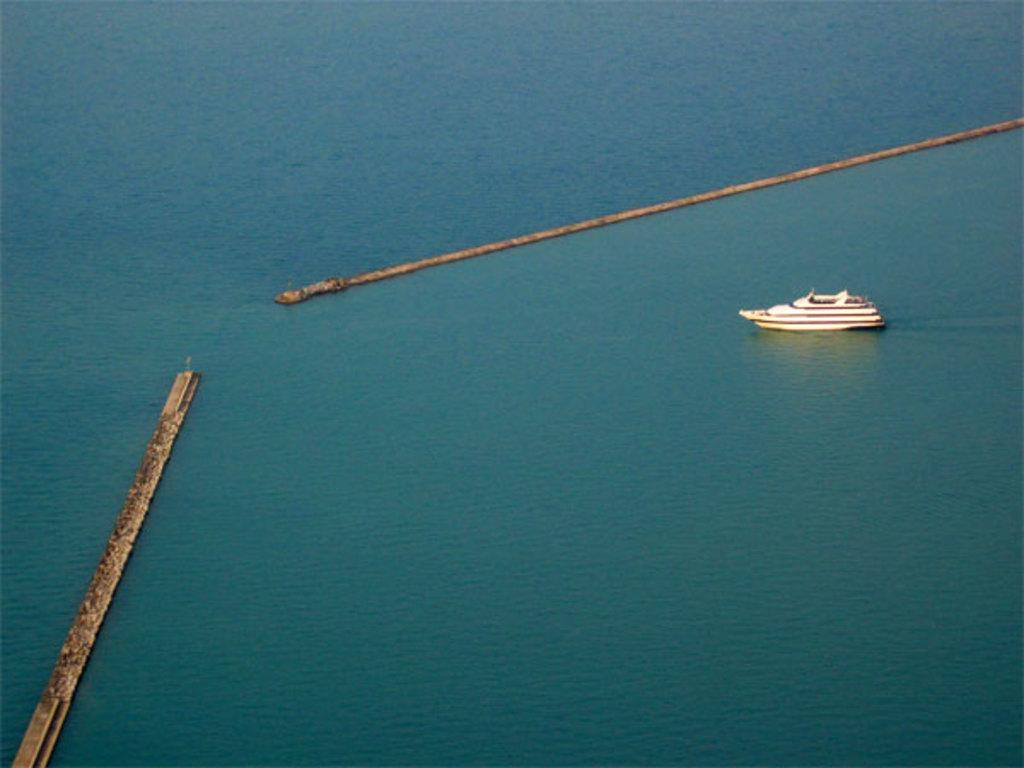What is the main subject of the image? The main subject of the image is a boat. Where is the boat located in the image? The boat is in the water. What other object can be seen in the image? There is a fence in the image. Can you describe the setting of the image? The image may have been taken in the ocean, given the presence of water. What type of butter is being used to grease the vessel in the image? There is no butter or vessel present in the image; it features a boat in the water and a fence. 